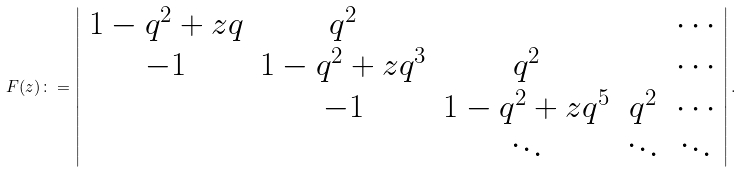Convert formula to latex. <formula><loc_0><loc_0><loc_500><loc_500>F ( z ) \colon = \left | \begin{array} { c c c c c } 1 - q ^ { 2 } + z q & q ^ { 2 } & & & \cdots \\ - 1 & 1 - q ^ { 2 } + z q ^ { 3 } & q ^ { 2 } & & \cdots \\ & - 1 & 1 - q ^ { 2 } + z q ^ { 5 } & q ^ { 2 } & \cdots \\ & & \ddots & \ddots & \ddots \\ \end{array} \right | .</formula> 